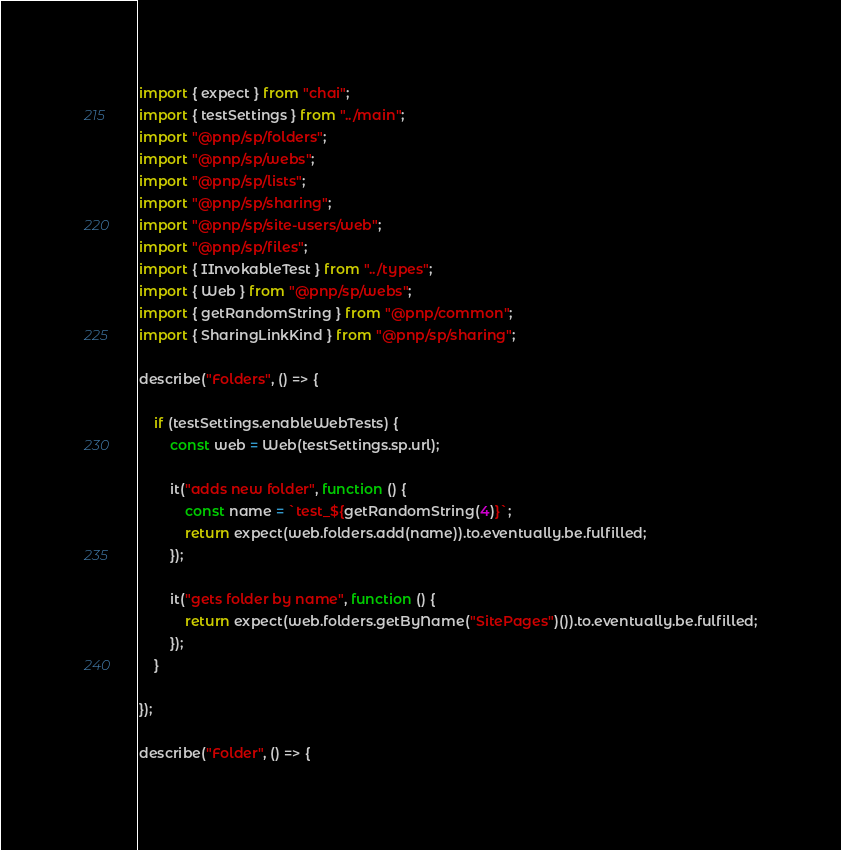<code> <loc_0><loc_0><loc_500><loc_500><_TypeScript_>import { expect } from "chai";
import { testSettings } from "../main";
import "@pnp/sp/folders";
import "@pnp/sp/webs";
import "@pnp/sp/lists";
import "@pnp/sp/sharing";
import "@pnp/sp/site-users/web";
import "@pnp/sp/files";
import { IInvokableTest } from "../types";
import { Web } from "@pnp/sp/webs";
import { getRandomString } from "@pnp/common";
import { SharingLinkKind } from "@pnp/sp/sharing";

describe("Folders", () => {

    if (testSettings.enableWebTests) {
        const web = Web(testSettings.sp.url);

        it("adds new folder", function () {
            const name = `test_${getRandomString(4)}`;
            return expect(web.folders.add(name)).to.eventually.be.fulfilled;
        });

        it("gets folder by name", function () {
            return expect(web.folders.getByName("SitePages")()).to.eventually.be.fulfilled;
        });
    }

});

describe("Folder", () => {
</code> 